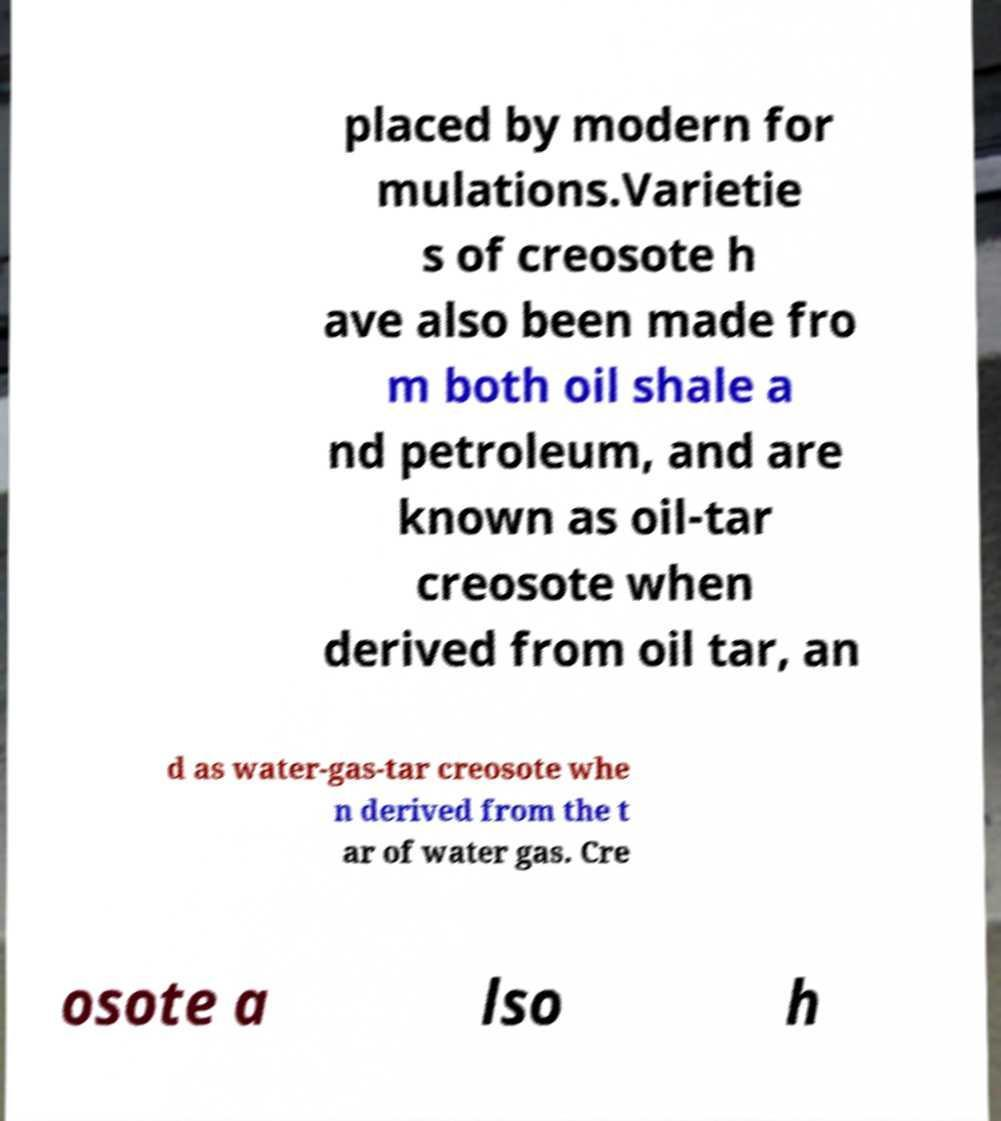Could you assist in decoding the text presented in this image and type it out clearly? placed by modern for mulations.Varietie s of creosote h ave also been made fro m both oil shale a nd petroleum, and are known as oil-tar creosote when derived from oil tar, an d as water-gas-tar creosote whe n derived from the t ar of water gas. Cre osote a lso h 